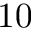<formula> <loc_0><loc_0><loc_500><loc_500>1 0</formula> 